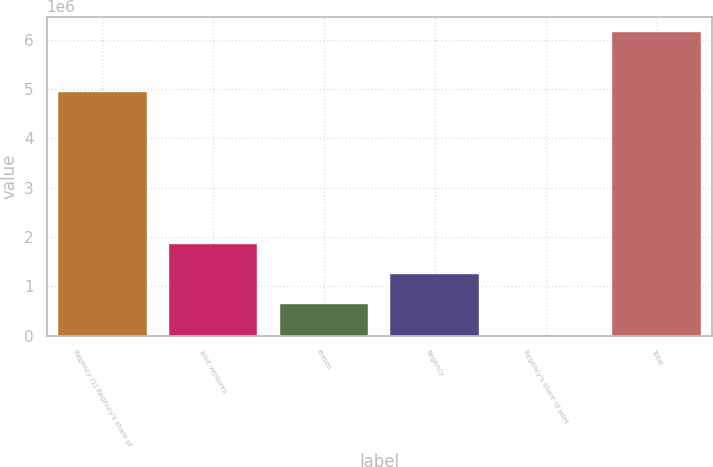<chart> <loc_0><loc_0><loc_500><loc_500><bar_chart><fcel>Regency (1) Regency's share of<fcel>joint ventures<fcel>leases<fcel>Regency<fcel>Regency's share of joint<fcel>Total<nl><fcel>4.93548e+06<fcel>1.86302e+06<fcel>634366<fcel>1.24869e+06<fcel>20042<fcel>6.16329e+06<nl></chart> 